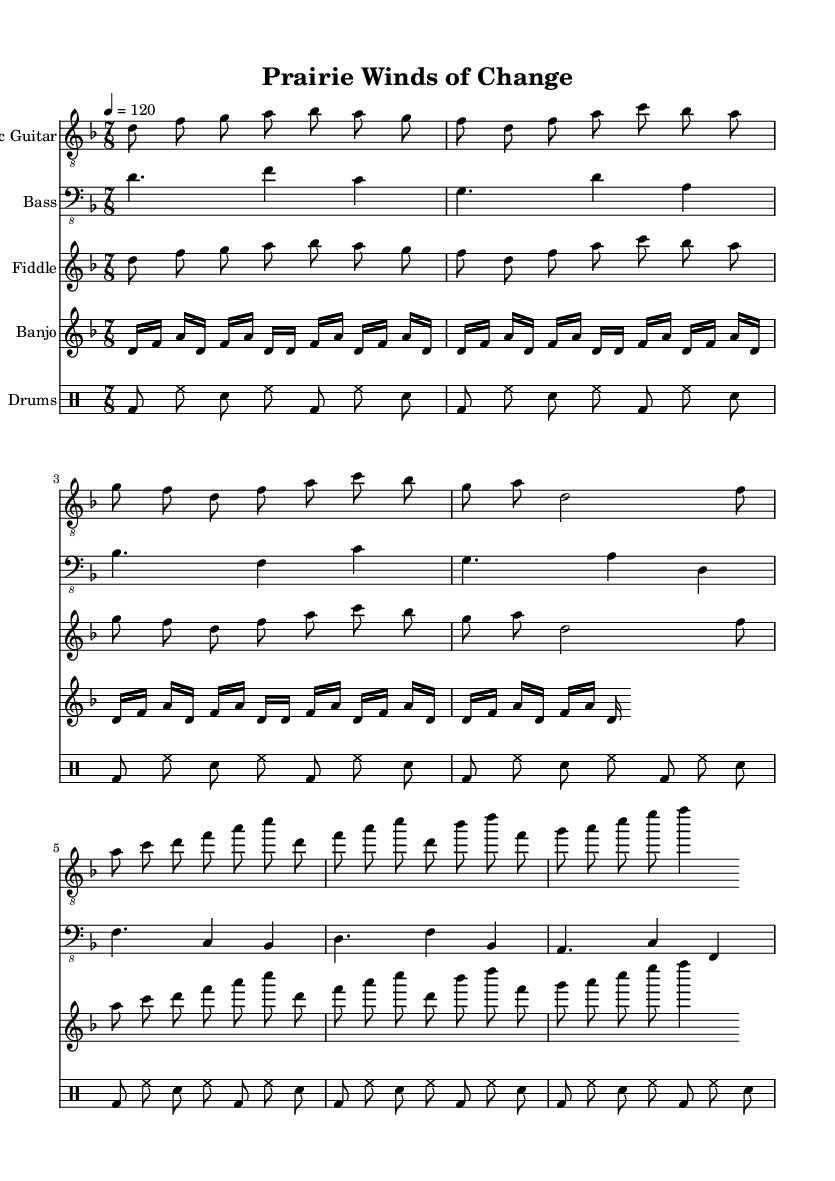What is the key signature of this music? The key signature is indicated at the beginning of the music sheet. Here, it shows one flat (B♭) which identifies it as D minor.
Answer: D minor What is the time signature of this piece? The time signature is located at the start of the music. It is shown as 7/8, indicating there are seven eighth notes in a measure.
Answer: 7/8 What is the tempo marking for this piece? The tempo marking is found near the top and specifies how fast the music should be played. It indicates a speed of 120 beats per minute.
Answer: 120 How many instruments are featured in this composition? By counting the number of staves in the score, we can determine the number of instruments. There are five distinct staves for five instruments.
Answer: Five What genre does "Prairie Winds of Change" represent? By analyzing the style of the musical elements present in the score, including the combination of electric guitar, folk instruments, and progressive structures, we can identify it as Progressive Metal.
Answer: Progressive Metal What kind of rhythm is predominantly used in the electric guitar part? Looking at the rhythmic structure of the electric guitar, it shows the consistent use of eighth notes and a combination of longer and shorter notes. This gives a progressive feel typical in Metal music.
Answer: Eighth notes 